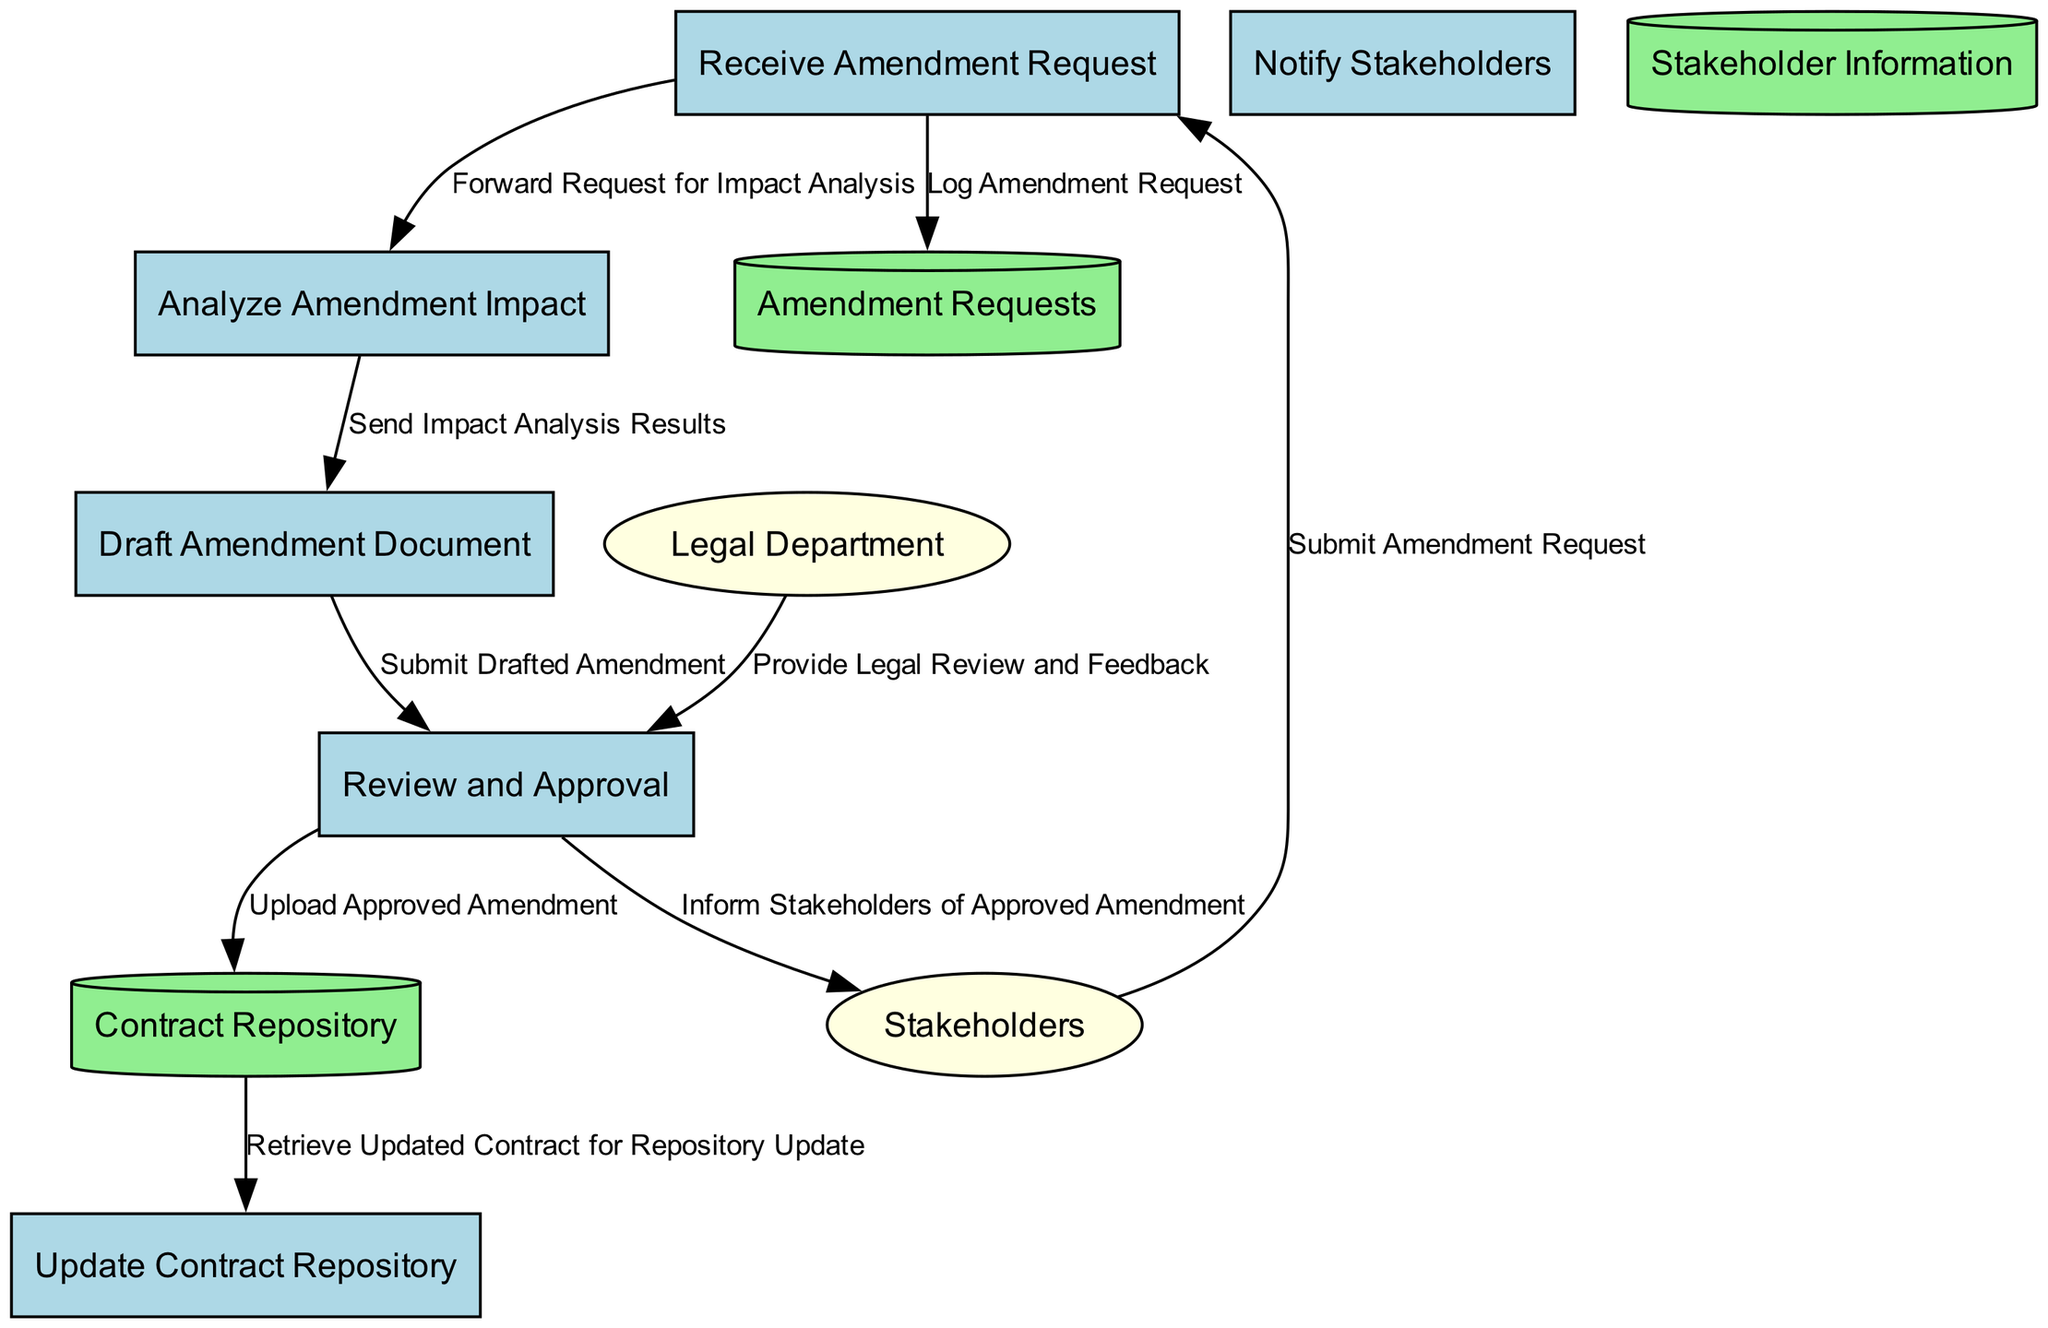What is the first process in the diagram? The first process is designated by the label "P1", which is the first node listed in the processes. It has the name "Receive Amendment Request".
Answer: Receive Amendment Request How many data stores are present in the diagram? By counting the nodes categorized as data stores, we have three: "Contract Repository", "Amendment Requests", and "Stakeholder Information".
Answer: 3 What external entity submits an amendment request? The external entity that submits a request is labeled "EE1" in the diagram and named "Stakeholders".
Answer: Stakeholders Which process reviews and approves the drafted amendment document? The process responsible for reviewing and approving the document is labeled "P4" and is named "Review and Approval".
Answer: Review and Approval What flows from the "Analyze Amendment Impact" process to the "Draft Amendment Document" process? The data flow going from "P2" (Analyze Amendment Impact) to "P3" (Draft Amendment Document) is described as "Send Impact Analysis Results".
Answer: Send Impact Analysis Results Which external entity provides legal review and feedback? The external entity providing legal review and feedback is labeled as "EE2" and named "Legal Department".
Answer: Legal Department What happens after the "Review and Approval" process? Following the "Review and Approval" process, the approved amendment document is uploaded to the "Contract Repository" as indicated by the flow from "P4" to "DS1".
Answer: Upload Approved Amendment How does the "Draft Amendment Document" process receive information? The "Draft Amendment Document" process receives information from "Analyze Amendment Impact" indicated by the flow labeled "Send Impact Analysis Results".
Answer: Send Impact Analysis Results What is the last step shown in the diagram? The last step in the depicted process is the notification to stakeholders after the amendment is approved, as indicated by the flow from "P4" to "EE1".
Answer: Inform Stakeholders of Approved Amendment 